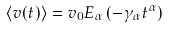<formula> <loc_0><loc_0><loc_500><loc_500>\langle v ( t ) \rangle = v _ { 0 } E _ { \alpha } \left ( - \gamma _ { \alpha } t ^ { \alpha } \right )</formula> 